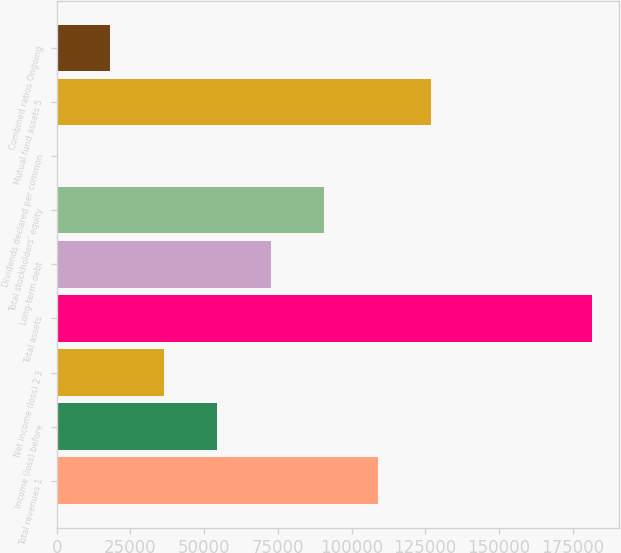Convert chart. <chart><loc_0><loc_0><loc_500><loc_500><bar_chart><fcel>Total revenues 1<fcel>Income (loss) before<fcel>Net income (loss) 2 3<fcel>Total assets<fcel>Long-term debt<fcel>Total stockholders' equity<fcel>Dividends declared per common<fcel>Mutual fund assets 5<fcel>Combined ratios Ongoing<nl><fcel>108954<fcel>54477.7<fcel>36318.8<fcel>181590<fcel>72636.6<fcel>90795.5<fcel>1.01<fcel>127113<fcel>18159.9<nl></chart> 